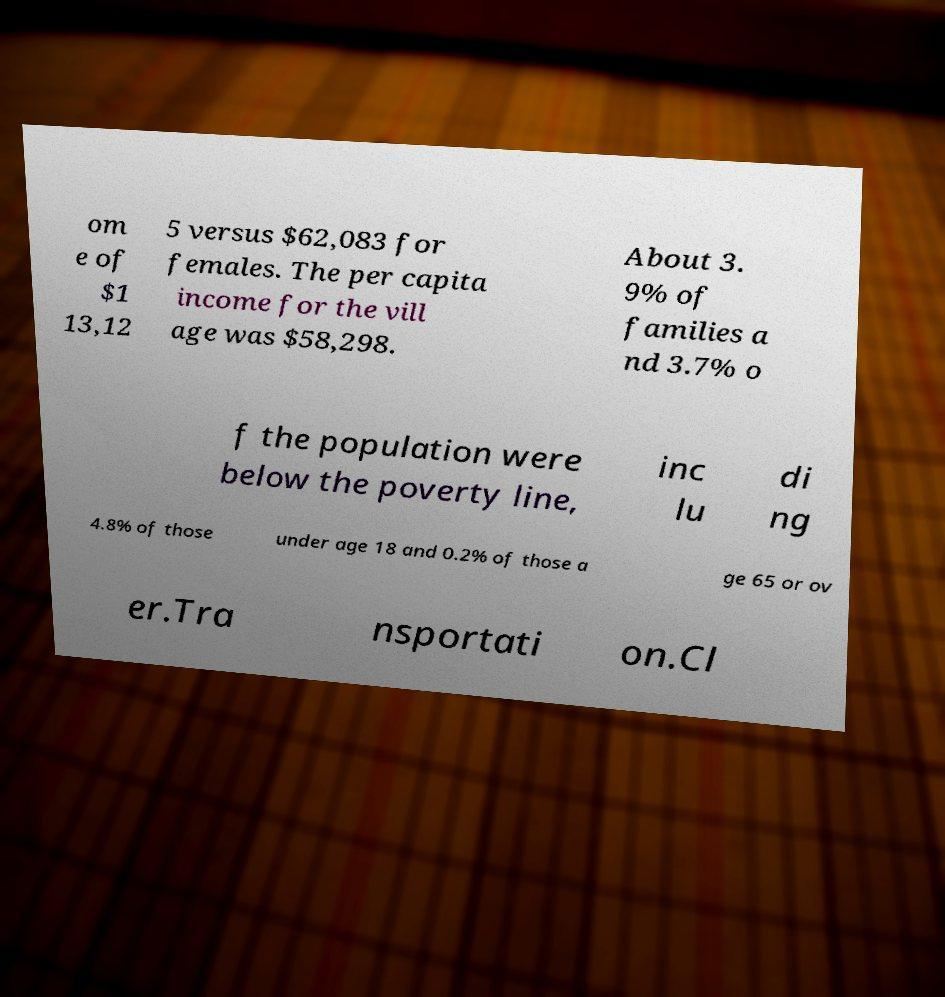For documentation purposes, I need the text within this image transcribed. Could you provide that? om e of $1 13,12 5 versus $62,083 for females. The per capita income for the vill age was $58,298. About 3. 9% of families a nd 3.7% o f the population were below the poverty line, inc lu di ng 4.8% of those under age 18 and 0.2% of those a ge 65 or ov er.Tra nsportati on.Cl 